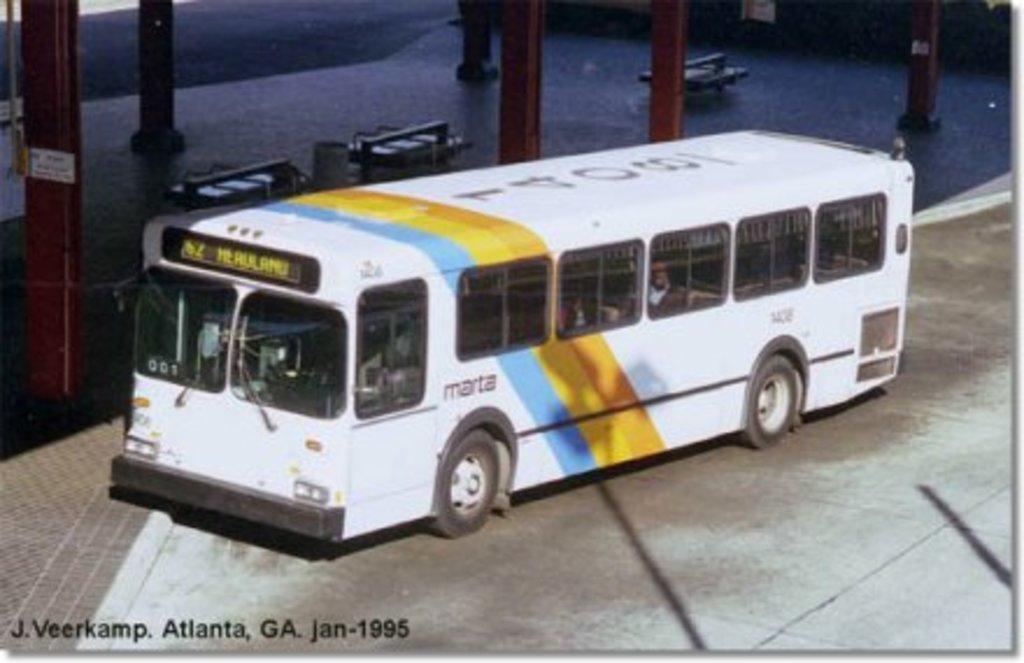Where is this?
Ensure brevity in your answer.  Atlanta, ga. 